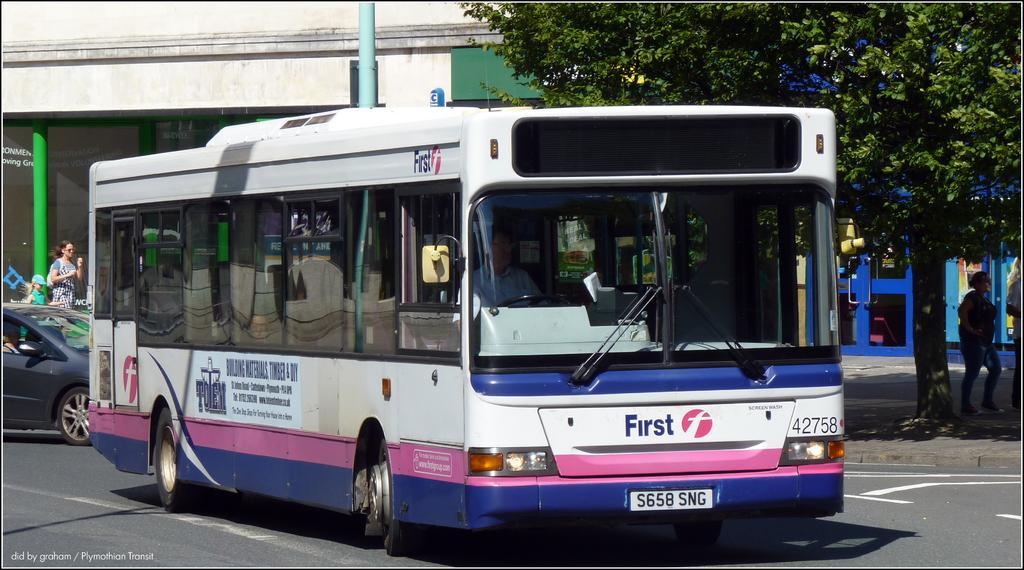In one or two sentences, can you explain what this image depicts? In this image there are buildings towards the top of the image, there is a pillar towards the left of the image, there is a pole towards the top of the image, there is a wall towards the top of the image, there is a tree towards the top of the image, there is a board towards the left of the image, there is text on the board, there is a woman walking, she is wearing a bag, she is holding an object, there is a girl walking towards the left of the image, she is wearing a cap, there is a woman standing towards the right of the image, there is a door, there is road towards the bottom of the image, there is a bus on the road, there is a man driving a bus, there is a car towards the left of the image, there is text towards the bottom of the image. 